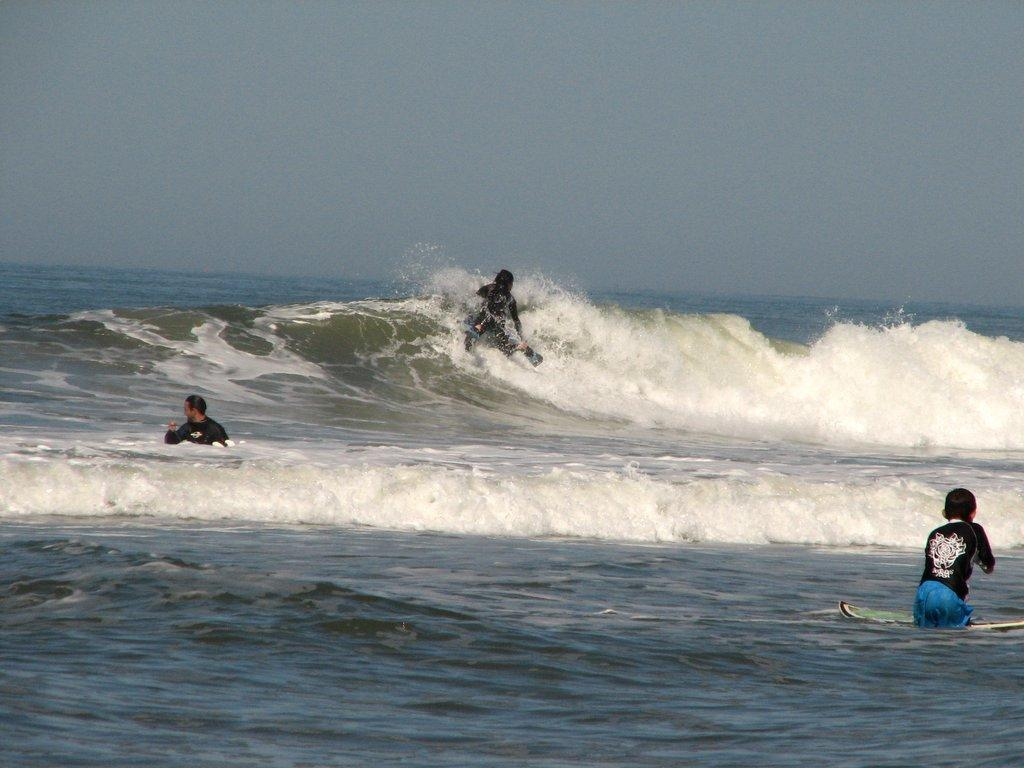What is present in the image? There is water and people in the water in the image. What can be seen in the background of the image? The sky is visible in the image. What type of page can be seen in the image? There is no page present in the image; it features water and people in the water. Are there any icicles visible in the image? There are no icicles present in the image; it features water and people in the water. 